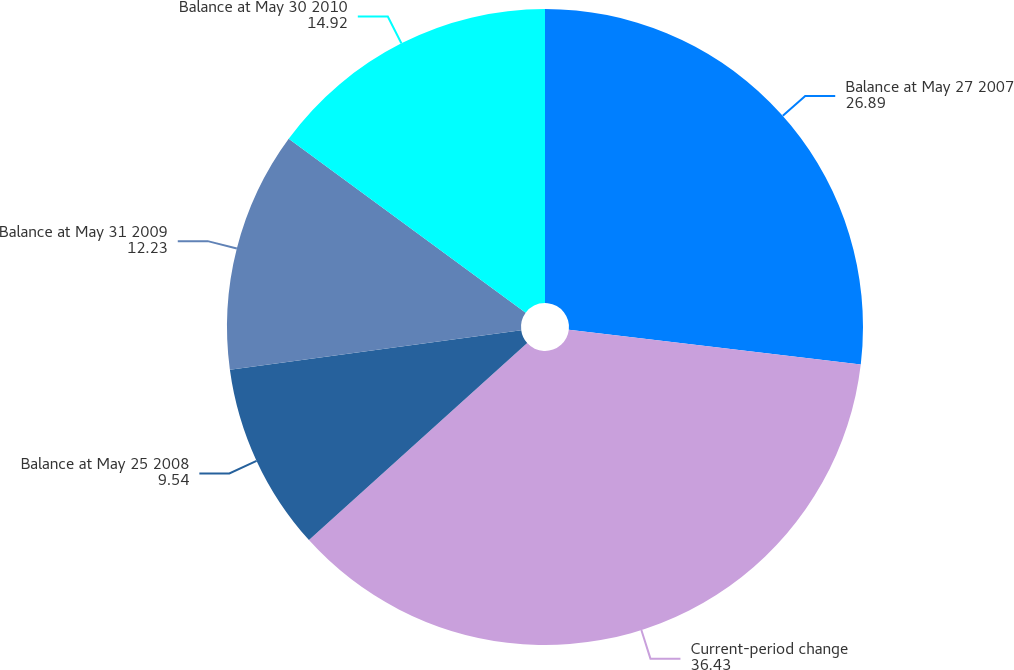Convert chart to OTSL. <chart><loc_0><loc_0><loc_500><loc_500><pie_chart><fcel>Balance at May 27 2007<fcel>Current-period change<fcel>Balance at May 25 2008<fcel>Balance at May 31 2009<fcel>Balance at May 30 2010<nl><fcel>26.89%<fcel>36.43%<fcel>9.54%<fcel>12.23%<fcel>14.92%<nl></chart> 